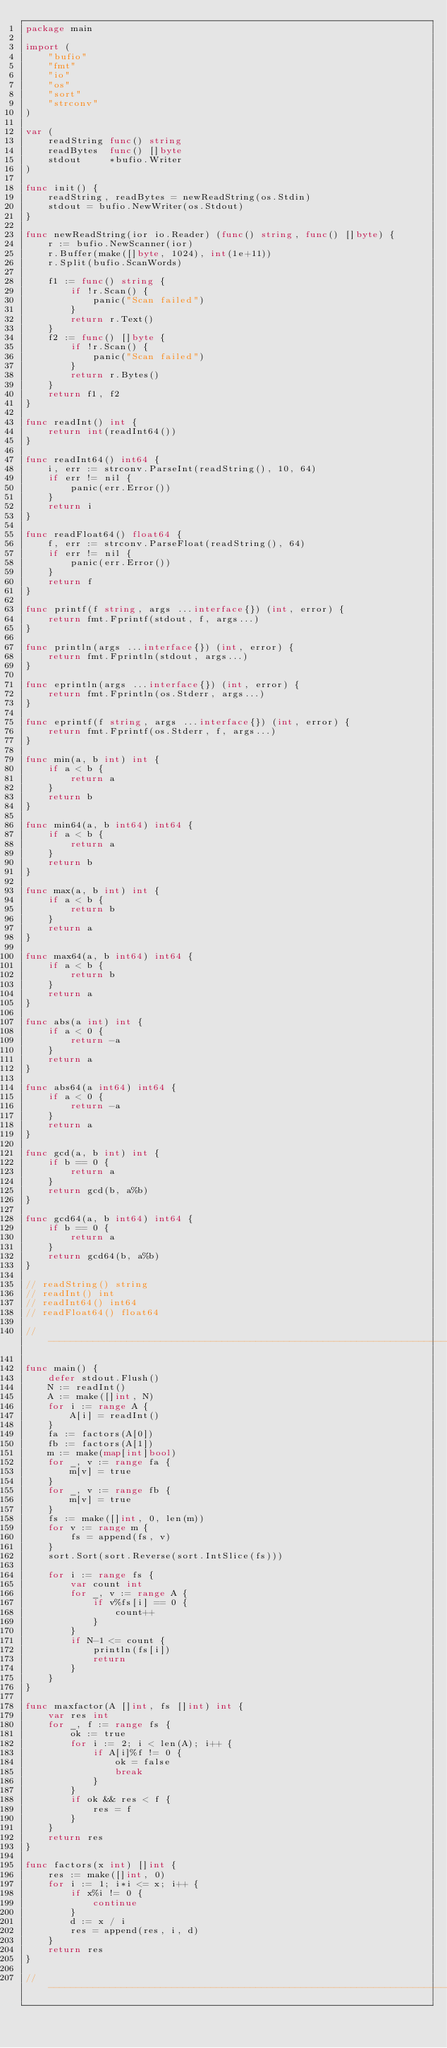<code> <loc_0><loc_0><loc_500><loc_500><_Go_>package main

import (
	"bufio"
	"fmt"
	"io"
	"os"
	"sort"
	"strconv"
)

var (
	readString func() string
	readBytes  func() []byte
	stdout     *bufio.Writer
)

func init() {
	readString, readBytes = newReadString(os.Stdin)
	stdout = bufio.NewWriter(os.Stdout)
}

func newReadString(ior io.Reader) (func() string, func() []byte) {
	r := bufio.NewScanner(ior)
	r.Buffer(make([]byte, 1024), int(1e+11))
	r.Split(bufio.ScanWords)

	f1 := func() string {
		if !r.Scan() {
			panic("Scan failed")
		}
		return r.Text()
	}
	f2 := func() []byte {
		if !r.Scan() {
			panic("Scan failed")
		}
		return r.Bytes()
	}
	return f1, f2
}

func readInt() int {
	return int(readInt64())
}

func readInt64() int64 {
	i, err := strconv.ParseInt(readString(), 10, 64)
	if err != nil {
		panic(err.Error())
	}
	return i
}

func readFloat64() float64 {
	f, err := strconv.ParseFloat(readString(), 64)
	if err != nil {
		panic(err.Error())
	}
	return f
}

func printf(f string, args ...interface{}) (int, error) {
	return fmt.Fprintf(stdout, f, args...)
}

func println(args ...interface{}) (int, error) {
	return fmt.Fprintln(stdout, args...)
}

func eprintln(args ...interface{}) (int, error) {
	return fmt.Fprintln(os.Stderr, args...)
}

func eprintf(f string, args ...interface{}) (int, error) {
	return fmt.Fprintf(os.Stderr, f, args...)
}

func min(a, b int) int {
	if a < b {
		return a
	}
	return b
}

func min64(a, b int64) int64 {
	if a < b {
		return a
	}
	return b
}

func max(a, b int) int {
	if a < b {
		return b
	}
	return a
}

func max64(a, b int64) int64 {
	if a < b {
		return b
	}
	return a
}

func abs(a int) int {
	if a < 0 {
		return -a
	}
	return a
}

func abs64(a int64) int64 {
	if a < 0 {
		return -a
	}
	return a
}

func gcd(a, b int) int {
	if b == 0 {
		return a
	}
	return gcd(b, a%b)
}

func gcd64(a, b int64) int64 {
	if b == 0 {
		return a
	}
	return gcd64(b, a%b)
}

// readString() string
// readInt() int
// readInt64() int64
// readFloat64() float64

// -----------------------------------------------------------------------------

func main() {
	defer stdout.Flush()
	N := readInt()
	A := make([]int, N)
	for i := range A {
		A[i] = readInt()
	}
	fa := factors(A[0])
	fb := factors(A[1])
	m := make(map[int]bool)
	for _, v := range fa {
		m[v] = true
	}
	for _, v := range fb {
		m[v] = true
	}
	fs := make([]int, 0, len(m))
	for v := range m {
		fs = append(fs, v)
	}
	sort.Sort(sort.Reverse(sort.IntSlice(fs)))

	for i := range fs {
		var count int
		for _, v := range A {
			if v%fs[i] == 0 {
				count++
			}
		}
		if N-1 <= count {
			println(fs[i])
			return
		}
	}
}

func maxfactor(A []int, fs []int) int {
	var res int
	for _, f := range fs {
		ok := true
		for i := 2; i < len(A); i++ {
			if A[i]%f != 0 {
				ok = false
				break
			}
		}
		if ok && res < f {
			res = f
		}
	}
	return res
}

func factors(x int) []int {
	res := make([]int, 0)
	for i := 1; i*i <= x; i++ {
		if x%i != 0 {
			continue
		}
		d := x / i
		res = append(res, i, d)
	}
	return res
}

// -----------------------------------------------------------------------------
</code> 